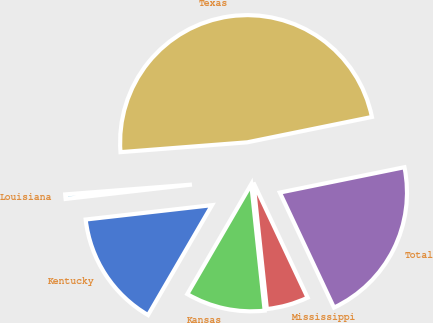Convert chart. <chart><loc_0><loc_0><loc_500><loc_500><pie_chart><fcel>Kentucky<fcel>Kansas<fcel>Mississippi<fcel>Total<fcel>Texas<fcel>Louisiana<nl><fcel>14.81%<fcel>10.07%<fcel>5.32%<fcel>21.19%<fcel>48.04%<fcel>0.57%<nl></chart> 